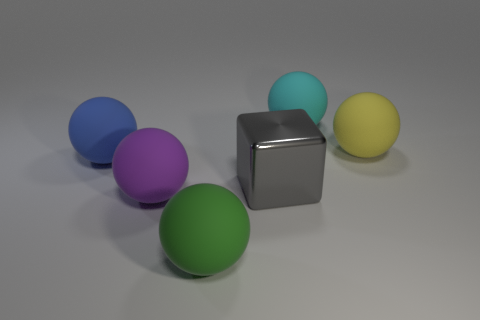How many objects are there in the image, and can you describe their arrangement? There are six objects in the image: five spheres and one cube. They are arranged with one sphere and the cube in the front, while the rest are grouped slightly behind. The cube is centrally located at the front with a green sphere to its left and the cyan sphere behind it, slightly to the right. Can you identify the colors of these objects? Certainly! Starting from the left, there is a blue sphere, then a green one. In the middle, there's a gray cube. Behind the cube and slightly to the right, there's a cyan sphere. To the right, there's a yellow sphere, and finally, on the far right, there's a purple sphere. 